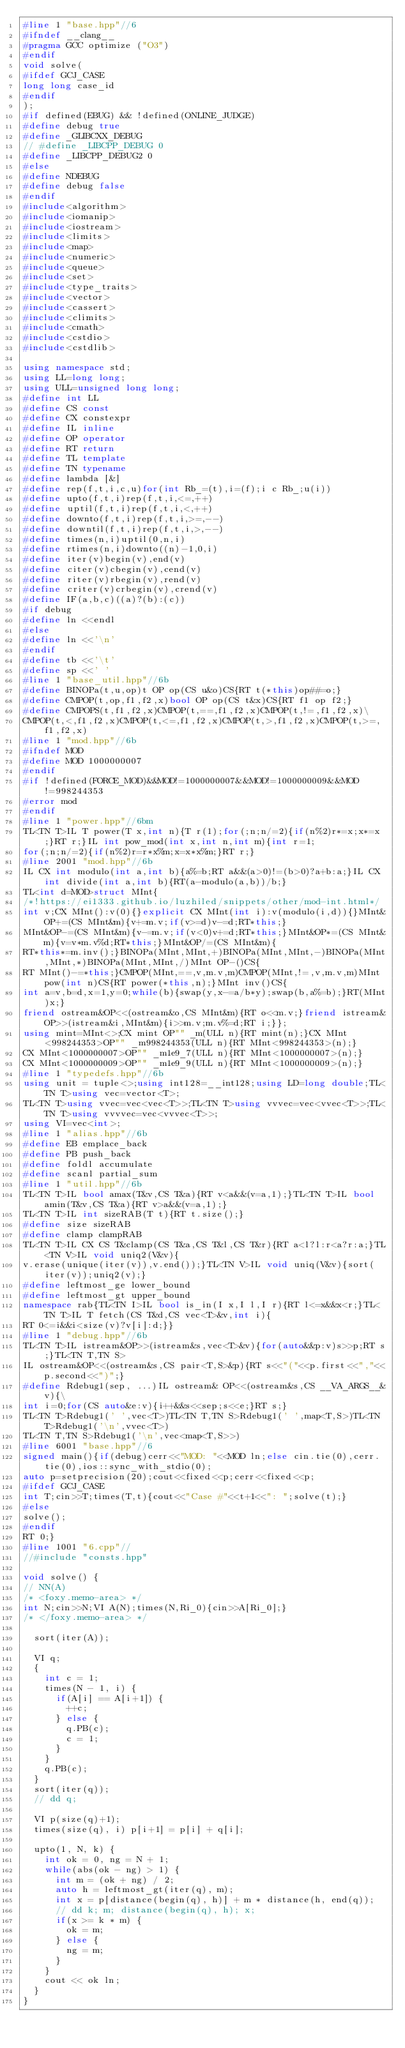<code> <loc_0><loc_0><loc_500><loc_500><_C++_>#line 1 "base.hpp"//6
#ifndef __clang__
#pragma GCC optimize ("O3")
#endif
void solve(
#ifdef GCJ_CASE
long long case_id
#endif
);
#if defined(EBUG) && !defined(ONLINE_JUDGE)
#define debug true
#define _GLIBCXX_DEBUG
// #define _LIBCPP_DEBUG 0
#define _LIBCPP_DEBUG2 0
#else
#define NDEBUG
#define debug false
#endif
#include<algorithm>
#include<iomanip>
#include<iostream>
#include<limits>
#include<map>
#include<numeric>
#include<queue>
#include<set>
#include<type_traits>
#include<vector>
#include<cassert>
#include<climits>
#include<cmath>
#include<cstdio>
#include<cstdlib>

using namespace std;
using LL=long long;
using ULL=unsigned long long;
#define int LL
#define CS const
#define CX constexpr
#define IL inline
#define OP operator
#define RT return
#define TL template
#define TN typename
#define lambda [&]
#define rep(f,t,i,c,u)for(int Rb_=(t),i=(f);i c Rb_;u(i))
#define upto(f,t,i)rep(f,t,i,<=,++)
#define uptil(f,t,i)rep(f,t,i,<,++)
#define downto(f,t,i)rep(f,t,i,>=,--)
#define downtil(f,t,i)rep(f,t,i,>,--)
#define times(n,i)uptil(0,n,i)
#define rtimes(n,i)downto((n)-1,0,i)
#define iter(v)begin(v),end(v)
#define citer(v)cbegin(v),cend(v)
#define riter(v)rbegin(v),rend(v)
#define criter(v)crbegin(v),crend(v)
#define IF(a,b,c)((a)?(b):(c))
#if debug
#define ln <<endl
#else
#define ln <<'\n'
#endif
#define tb <<'\t'
#define sp <<' '
#line 1 "base_util.hpp"//6b
#define BINOPa(t,u,op)t OP op(CS u&o)CS{RT t(*this)op##=o;}
#define CMPOP(t,op,f1,f2,x)bool OP op(CS t&x)CS{RT f1 op f2;}
#define CMPOPS(t,f1,f2,x)CMPOP(t,==,f1,f2,x)CMPOP(t,!=,f1,f2,x)\
CMPOP(t,<,f1,f2,x)CMPOP(t,<=,f1,f2,x)CMPOP(t,>,f1,f2,x)CMPOP(t,>=,f1,f2,x)
#line 1 "mod.hpp"//6b
#ifndef MOD
#define MOD 1000000007
#endif
#if !defined(FORCE_MOD)&&MOD!=1000000007&&MOD!=1000000009&&MOD!=998244353
#error mod
#endif
#line 1 "power.hpp"//6bm
TL<TN T>IL T power(T x,int n){T r(1);for(;n;n/=2){if(n%2)r*=x;x*=x;}RT r;}IL int pow_mod(int x,int n,int m){int r=1;
for(;n;n/=2){if(n%2)r=r*x%m;x=x*x%m;}RT r;}
#line 2001 "mod.hpp"//6b
IL CX int modulo(int a,int b){a%=b;RT a&&(a>0)!=(b>0)?a+b:a;}IL CX int divide(int a,int b){RT(a-modulo(a,b))/b;}
TL<int d=MOD>struct MInt{
/*!https://ei1333.github.io/luzhiled/snippets/other/mod-int.html*/
int v;CX MInt():v(0){}explicit CX MInt(int i):v(modulo(i,d)){}MInt&OP+=(CS MInt&m){v+=m.v;if(v>=d)v-=d;RT*this;}
MInt&OP-=(CS MInt&m){v-=m.v;if(v<0)v+=d;RT*this;}MInt&OP*=(CS MInt&m){v=v*m.v%d;RT*this;}MInt&OP/=(CS MInt&m){
RT*this*=m.inv();}BINOPa(MInt,MInt,+)BINOPa(MInt,MInt,-)BINOPa(MInt,MInt,*)BINOPa(MInt,MInt,/)MInt OP-()CS{
RT MInt()-=*this;}CMPOP(MInt,==,v,m.v,m)CMPOP(MInt,!=,v,m.v,m)MInt pow(int n)CS{RT power(*this,n);}MInt inv()CS{
int a=v,b=d,x=1,y=0;while(b){swap(y,x-=a/b*y);swap(b,a%=b);}RT(MInt)x;}
friend ostream&OP<<(ostream&o,CS MInt&m){RT o<<m.v;}friend istream&OP>>(istream&i,MInt&m){i>>m.v;m.v%=d;RT i;}};
using mint=MInt<>;CX mint OP"" _m(ULL n){RT mint(n);}CX MInt<998244353>OP"" _m998244353(ULL n){RT MInt<998244353>(n);}
CX MInt<1000000007>OP"" _m1e9_7(ULL n){RT MInt<1000000007>(n);}
CX MInt<1000000009>OP"" _m1e9_9(ULL n){RT MInt<1000000009>(n);}
#line 1 "typedefs.hpp"//6b
using unit = tuple<>;using int128=__int128;using LD=long double;TL<TN T>using vec=vector<T>;
TL<TN T>using vvec=vec<vec<T>>;TL<TN T>using vvvec=vec<vvec<T>>;TL<TN T>using vvvvec=vec<vvvec<T>>;
using VI=vec<int>;
#line 1 "alias.hpp"//6b
#define EB emplace_back
#define PB push_back
#define foldl accumulate
#define scanl partial_sum
#line 1 "util.hpp"//6b
TL<TN T>IL bool amax(T&v,CS T&a){RT v<a&&(v=a,1);}TL<TN T>IL bool amin(T&v,CS T&a){RT v>a&&(v=a,1);}
TL<TN T>IL int sizeRAB(T t){RT t.size();}
#define size sizeRAB
#define clamp clampRAB
TL<TN T>IL CX CS T&clamp(CS T&a,CS T&l,CS T&r){RT a<l?l:r<a?r:a;}TL<TN V>IL void uniq2(V&v){
v.erase(unique(iter(v)),v.end());}TL<TN V>IL void uniq(V&v){sort(iter(v));uniq2(v);}
#define leftmost_ge lower_bound
#define leftmost_gt upper_bound
namespace rab{TL<TN I>IL bool is_in(I x,I l,I r){RT l<=x&&x<r;}TL<TN T>IL T fetch(CS T&d,CS vec<T>&v,int i){
RT 0<=i&&i<size(v)?v[i]:d;}}
#line 1 "debug.hpp"//6b
TL<TN T>IL istream&OP>>(istream&s,vec<T>&v){for(auto&&p:v)s>>p;RT s;}TL<TN T,TN S>
IL ostream&OP<<(ostream&s,CS pair<T,S>&p){RT s<<"("<<p.first<<","<<p.second<<")";}
#define Rdebug1(sep, ...)IL ostream& OP<<(ostream&s,CS __VA_ARGS__&v){\
int i=0;for(CS auto&e:v){i++&&s<<sep;s<<e;}RT s;}
TL<TN T>Rdebug1(' ',vec<T>)TL<TN T,TN S>Rdebug1(' ',map<T,S>)TL<TN T>Rdebug1('\n',vvec<T>)
TL<TN T,TN S>Rdebug1('\n',vec<map<T,S>>)
#line 6001 "base.hpp"//6
signed main(){if(debug)cerr<<"MOD: "<<MOD ln;else cin.tie(0),cerr.tie(0),ios::sync_with_stdio(0);
auto p=setprecision(20);cout<<fixed<<p;cerr<<fixed<<p;
#ifdef GCJ_CASE
int T;cin>>T;times(T,t){cout<<"Case #"<<t+1<<": ";solve(t);}
#else
solve();
#endif
RT 0;}
#line 1001 "6.cpp"//
//#include "consts.hpp"

void solve() {
// NN(A)
/* <foxy.memo-area> */
int N;cin>>N;VI A(N);times(N,Ri_0){cin>>A[Ri_0];}
/* </foxy.memo-area> */

  sort(iter(A));

  VI q;
  {
    int c = 1;
    times(N - 1, i) {
      if(A[i] == A[i+1]) {
        ++c;
      } else {
        q.PB(c);
        c = 1;
      }
    }
    q.PB(c);
  }
  sort(iter(q));
  // dd q;

  VI p(size(q)+1);
  times(size(q), i) p[i+1] = p[i] + q[i];

  upto(1, N, k) {
    int ok = 0, ng = N + 1;
    while(abs(ok - ng) > 1) {
      int m = (ok + ng) / 2;
      auto h = leftmost_gt(iter(q), m);
      int x = p[distance(begin(q), h)] + m * distance(h, end(q));
      // dd k; m; distance(begin(q), h); x;
      if(x >= k * m) {
        ok = m;
      } else {
        ng = m;
      }
    }
    cout << ok ln;
  }
}
</code> 